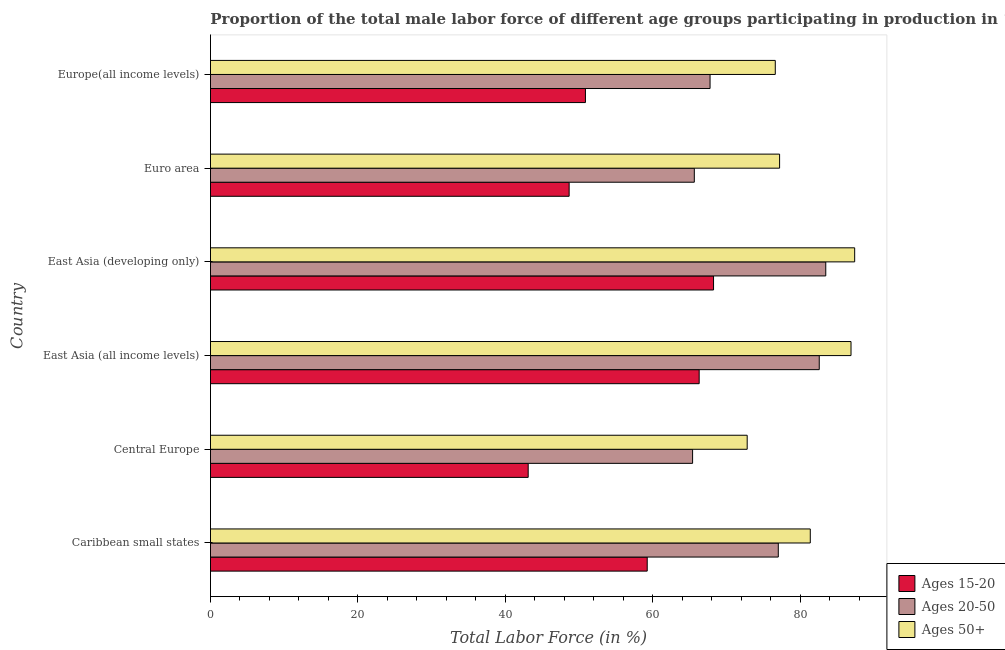How many groups of bars are there?
Provide a succinct answer. 6. Are the number of bars per tick equal to the number of legend labels?
Your response must be concise. Yes. Are the number of bars on each tick of the Y-axis equal?
Keep it short and to the point. Yes. How many bars are there on the 1st tick from the top?
Provide a short and direct response. 3. How many bars are there on the 6th tick from the bottom?
Offer a very short reply. 3. What is the label of the 1st group of bars from the top?
Offer a terse response. Europe(all income levels). What is the percentage of male labor force within the age group 20-50 in Euro area?
Offer a very short reply. 65.61. Across all countries, what is the maximum percentage of male labor force within the age group 20-50?
Make the answer very short. 83.43. Across all countries, what is the minimum percentage of male labor force within the age group 15-20?
Ensure brevity in your answer.  43.08. In which country was the percentage of male labor force within the age group 15-20 maximum?
Your answer should be compact. East Asia (developing only). In which country was the percentage of male labor force within the age group 15-20 minimum?
Offer a very short reply. Central Europe. What is the total percentage of male labor force within the age group 20-50 in the graph?
Your answer should be compact. 441.71. What is the difference between the percentage of male labor force above age 50 in Euro area and that in Europe(all income levels)?
Offer a very short reply. 0.58. What is the difference between the percentage of male labor force within the age group 20-50 in Central Europe and the percentage of male labor force within the age group 15-20 in Caribbean small states?
Make the answer very short. 6.15. What is the average percentage of male labor force within the age group 20-50 per country?
Offer a very short reply. 73.62. What is the difference between the percentage of male labor force within the age group 15-20 and percentage of male labor force above age 50 in Europe(all income levels)?
Your answer should be very brief. -25.74. What is the ratio of the percentage of male labor force within the age group 20-50 in Central Europe to that in East Asia (all income levels)?
Keep it short and to the point. 0.79. Is the percentage of male labor force above age 50 in Central Europe less than that in East Asia (developing only)?
Your answer should be compact. Yes. Is the difference between the percentage of male labor force above age 50 in Central Europe and East Asia (all income levels) greater than the difference between the percentage of male labor force within the age group 15-20 in Central Europe and East Asia (all income levels)?
Provide a short and direct response. Yes. What is the difference between the highest and the second highest percentage of male labor force within the age group 15-20?
Offer a terse response. 1.95. What is the difference between the highest and the lowest percentage of male labor force within the age group 15-20?
Your response must be concise. 25.14. What does the 2nd bar from the top in East Asia (all income levels) represents?
Offer a terse response. Ages 20-50. What does the 1st bar from the bottom in Euro area represents?
Your answer should be compact. Ages 15-20. How many bars are there?
Keep it short and to the point. 18. Are all the bars in the graph horizontal?
Your response must be concise. Yes. Does the graph contain any zero values?
Provide a short and direct response. No. Does the graph contain grids?
Ensure brevity in your answer.  No. Where does the legend appear in the graph?
Offer a very short reply. Bottom right. How are the legend labels stacked?
Offer a terse response. Vertical. What is the title of the graph?
Give a very brief answer. Proportion of the total male labor force of different age groups participating in production in 1999. What is the label or title of the X-axis?
Ensure brevity in your answer.  Total Labor Force (in %). What is the Total Labor Force (in %) of Ages 15-20 in Caribbean small states?
Make the answer very short. 59.22. What is the Total Labor Force (in %) of Ages 20-50 in Caribbean small states?
Your response must be concise. 77. What is the Total Labor Force (in %) of Ages 50+ in Caribbean small states?
Make the answer very short. 81.33. What is the Total Labor Force (in %) of Ages 15-20 in Central Europe?
Your answer should be very brief. 43.08. What is the Total Labor Force (in %) of Ages 20-50 in Central Europe?
Keep it short and to the point. 65.37. What is the Total Labor Force (in %) in Ages 50+ in Central Europe?
Make the answer very short. 72.78. What is the Total Labor Force (in %) in Ages 15-20 in East Asia (all income levels)?
Make the answer very short. 66.27. What is the Total Labor Force (in %) of Ages 20-50 in East Asia (all income levels)?
Make the answer very short. 82.55. What is the Total Labor Force (in %) of Ages 50+ in East Asia (all income levels)?
Offer a terse response. 86.86. What is the Total Labor Force (in %) in Ages 15-20 in East Asia (developing only)?
Keep it short and to the point. 68.22. What is the Total Labor Force (in %) in Ages 20-50 in East Asia (developing only)?
Give a very brief answer. 83.43. What is the Total Labor Force (in %) in Ages 50+ in East Asia (developing only)?
Keep it short and to the point. 87.35. What is the Total Labor Force (in %) in Ages 15-20 in Euro area?
Your answer should be very brief. 48.64. What is the Total Labor Force (in %) in Ages 20-50 in Euro area?
Provide a short and direct response. 65.61. What is the Total Labor Force (in %) of Ages 50+ in Euro area?
Your answer should be compact. 77.17. What is the Total Labor Force (in %) of Ages 15-20 in Europe(all income levels)?
Provide a succinct answer. 50.85. What is the Total Labor Force (in %) in Ages 20-50 in Europe(all income levels)?
Your answer should be compact. 67.74. What is the Total Labor Force (in %) of Ages 50+ in Europe(all income levels)?
Ensure brevity in your answer.  76.59. Across all countries, what is the maximum Total Labor Force (in %) in Ages 15-20?
Keep it short and to the point. 68.22. Across all countries, what is the maximum Total Labor Force (in %) in Ages 20-50?
Ensure brevity in your answer.  83.43. Across all countries, what is the maximum Total Labor Force (in %) in Ages 50+?
Provide a succinct answer. 87.35. Across all countries, what is the minimum Total Labor Force (in %) of Ages 15-20?
Offer a terse response. 43.08. Across all countries, what is the minimum Total Labor Force (in %) in Ages 20-50?
Ensure brevity in your answer.  65.37. Across all countries, what is the minimum Total Labor Force (in %) of Ages 50+?
Offer a terse response. 72.78. What is the total Total Labor Force (in %) in Ages 15-20 in the graph?
Your answer should be compact. 336.27. What is the total Total Labor Force (in %) in Ages 20-50 in the graph?
Provide a short and direct response. 441.71. What is the total Total Labor Force (in %) of Ages 50+ in the graph?
Your answer should be compact. 482.08. What is the difference between the Total Labor Force (in %) of Ages 15-20 in Caribbean small states and that in Central Europe?
Give a very brief answer. 16.14. What is the difference between the Total Labor Force (in %) of Ages 20-50 in Caribbean small states and that in Central Europe?
Make the answer very short. 11.62. What is the difference between the Total Labor Force (in %) of Ages 50+ in Caribbean small states and that in Central Europe?
Keep it short and to the point. 8.56. What is the difference between the Total Labor Force (in %) in Ages 15-20 in Caribbean small states and that in East Asia (all income levels)?
Your answer should be compact. -7.05. What is the difference between the Total Labor Force (in %) of Ages 20-50 in Caribbean small states and that in East Asia (all income levels)?
Your answer should be compact. -5.55. What is the difference between the Total Labor Force (in %) in Ages 50+ in Caribbean small states and that in East Asia (all income levels)?
Offer a terse response. -5.52. What is the difference between the Total Labor Force (in %) in Ages 15-20 in Caribbean small states and that in East Asia (developing only)?
Offer a very short reply. -9. What is the difference between the Total Labor Force (in %) of Ages 20-50 in Caribbean small states and that in East Asia (developing only)?
Your response must be concise. -6.44. What is the difference between the Total Labor Force (in %) of Ages 50+ in Caribbean small states and that in East Asia (developing only)?
Offer a terse response. -6.02. What is the difference between the Total Labor Force (in %) in Ages 15-20 in Caribbean small states and that in Euro area?
Offer a very short reply. 10.59. What is the difference between the Total Labor Force (in %) in Ages 20-50 in Caribbean small states and that in Euro area?
Offer a very short reply. 11.39. What is the difference between the Total Labor Force (in %) in Ages 50+ in Caribbean small states and that in Euro area?
Provide a short and direct response. 4.16. What is the difference between the Total Labor Force (in %) in Ages 15-20 in Caribbean small states and that in Europe(all income levels)?
Provide a short and direct response. 8.38. What is the difference between the Total Labor Force (in %) of Ages 20-50 in Caribbean small states and that in Europe(all income levels)?
Your answer should be compact. 9.25. What is the difference between the Total Labor Force (in %) of Ages 50+ in Caribbean small states and that in Europe(all income levels)?
Your answer should be compact. 4.75. What is the difference between the Total Labor Force (in %) in Ages 15-20 in Central Europe and that in East Asia (all income levels)?
Offer a very short reply. -23.19. What is the difference between the Total Labor Force (in %) in Ages 20-50 in Central Europe and that in East Asia (all income levels)?
Your answer should be very brief. -17.18. What is the difference between the Total Labor Force (in %) in Ages 50+ in Central Europe and that in East Asia (all income levels)?
Make the answer very short. -14.08. What is the difference between the Total Labor Force (in %) in Ages 15-20 in Central Europe and that in East Asia (developing only)?
Your answer should be very brief. -25.14. What is the difference between the Total Labor Force (in %) in Ages 20-50 in Central Europe and that in East Asia (developing only)?
Your response must be concise. -18.06. What is the difference between the Total Labor Force (in %) of Ages 50+ in Central Europe and that in East Asia (developing only)?
Your answer should be compact. -14.58. What is the difference between the Total Labor Force (in %) of Ages 15-20 in Central Europe and that in Euro area?
Your answer should be compact. -5.55. What is the difference between the Total Labor Force (in %) in Ages 20-50 in Central Europe and that in Euro area?
Ensure brevity in your answer.  -0.23. What is the difference between the Total Labor Force (in %) of Ages 50+ in Central Europe and that in Euro area?
Offer a very short reply. -4.39. What is the difference between the Total Labor Force (in %) in Ages 15-20 in Central Europe and that in Europe(all income levels)?
Give a very brief answer. -7.76. What is the difference between the Total Labor Force (in %) in Ages 20-50 in Central Europe and that in Europe(all income levels)?
Ensure brevity in your answer.  -2.37. What is the difference between the Total Labor Force (in %) of Ages 50+ in Central Europe and that in Europe(all income levels)?
Your answer should be compact. -3.81. What is the difference between the Total Labor Force (in %) of Ages 15-20 in East Asia (all income levels) and that in East Asia (developing only)?
Your answer should be compact. -1.95. What is the difference between the Total Labor Force (in %) in Ages 20-50 in East Asia (all income levels) and that in East Asia (developing only)?
Your answer should be compact. -0.88. What is the difference between the Total Labor Force (in %) of Ages 50+ in East Asia (all income levels) and that in East Asia (developing only)?
Ensure brevity in your answer.  -0.5. What is the difference between the Total Labor Force (in %) of Ages 15-20 in East Asia (all income levels) and that in Euro area?
Make the answer very short. 17.63. What is the difference between the Total Labor Force (in %) of Ages 20-50 in East Asia (all income levels) and that in Euro area?
Your response must be concise. 16.94. What is the difference between the Total Labor Force (in %) in Ages 50+ in East Asia (all income levels) and that in Euro area?
Offer a terse response. 9.68. What is the difference between the Total Labor Force (in %) in Ages 15-20 in East Asia (all income levels) and that in Europe(all income levels)?
Give a very brief answer. 15.42. What is the difference between the Total Labor Force (in %) in Ages 20-50 in East Asia (all income levels) and that in Europe(all income levels)?
Your response must be concise. 14.81. What is the difference between the Total Labor Force (in %) in Ages 50+ in East Asia (all income levels) and that in Europe(all income levels)?
Offer a very short reply. 10.27. What is the difference between the Total Labor Force (in %) in Ages 15-20 in East Asia (developing only) and that in Euro area?
Your answer should be very brief. 19.58. What is the difference between the Total Labor Force (in %) of Ages 20-50 in East Asia (developing only) and that in Euro area?
Make the answer very short. 17.83. What is the difference between the Total Labor Force (in %) in Ages 50+ in East Asia (developing only) and that in Euro area?
Provide a short and direct response. 10.18. What is the difference between the Total Labor Force (in %) of Ages 15-20 in East Asia (developing only) and that in Europe(all income levels)?
Give a very brief answer. 17.37. What is the difference between the Total Labor Force (in %) of Ages 20-50 in East Asia (developing only) and that in Europe(all income levels)?
Your answer should be compact. 15.69. What is the difference between the Total Labor Force (in %) in Ages 50+ in East Asia (developing only) and that in Europe(all income levels)?
Your response must be concise. 10.77. What is the difference between the Total Labor Force (in %) of Ages 15-20 in Euro area and that in Europe(all income levels)?
Provide a succinct answer. -2.21. What is the difference between the Total Labor Force (in %) of Ages 20-50 in Euro area and that in Europe(all income levels)?
Your response must be concise. -2.14. What is the difference between the Total Labor Force (in %) in Ages 50+ in Euro area and that in Europe(all income levels)?
Ensure brevity in your answer.  0.58. What is the difference between the Total Labor Force (in %) in Ages 15-20 in Caribbean small states and the Total Labor Force (in %) in Ages 20-50 in Central Europe?
Your response must be concise. -6.15. What is the difference between the Total Labor Force (in %) of Ages 15-20 in Caribbean small states and the Total Labor Force (in %) of Ages 50+ in Central Europe?
Your response must be concise. -13.56. What is the difference between the Total Labor Force (in %) in Ages 20-50 in Caribbean small states and the Total Labor Force (in %) in Ages 50+ in Central Europe?
Ensure brevity in your answer.  4.22. What is the difference between the Total Labor Force (in %) of Ages 15-20 in Caribbean small states and the Total Labor Force (in %) of Ages 20-50 in East Asia (all income levels)?
Ensure brevity in your answer.  -23.33. What is the difference between the Total Labor Force (in %) in Ages 15-20 in Caribbean small states and the Total Labor Force (in %) in Ages 50+ in East Asia (all income levels)?
Your response must be concise. -27.63. What is the difference between the Total Labor Force (in %) of Ages 20-50 in Caribbean small states and the Total Labor Force (in %) of Ages 50+ in East Asia (all income levels)?
Provide a succinct answer. -9.86. What is the difference between the Total Labor Force (in %) in Ages 15-20 in Caribbean small states and the Total Labor Force (in %) in Ages 20-50 in East Asia (developing only)?
Your answer should be very brief. -24.21. What is the difference between the Total Labor Force (in %) of Ages 15-20 in Caribbean small states and the Total Labor Force (in %) of Ages 50+ in East Asia (developing only)?
Your answer should be very brief. -28.13. What is the difference between the Total Labor Force (in %) of Ages 20-50 in Caribbean small states and the Total Labor Force (in %) of Ages 50+ in East Asia (developing only)?
Give a very brief answer. -10.36. What is the difference between the Total Labor Force (in %) in Ages 15-20 in Caribbean small states and the Total Labor Force (in %) in Ages 20-50 in Euro area?
Ensure brevity in your answer.  -6.39. What is the difference between the Total Labor Force (in %) of Ages 15-20 in Caribbean small states and the Total Labor Force (in %) of Ages 50+ in Euro area?
Ensure brevity in your answer.  -17.95. What is the difference between the Total Labor Force (in %) of Ages 20-50 in Caribbean small states and the Total Labor Force (in %) of Ages 50+ in Euro area?
Provide a short and direct response. -0.18. What is the difference between the Total Labor Force (in %) in Ages 15-20 in Caribbean small states and the Total Labor Force (in %) in Ages 20-50 in Europe(all income levels)?
Your answer should be very brief. -8.52. What is the difference between the Total Labor Force (in %) of Ages 15-20 in Caribbean small states and the Total Labor Force (in %) of Ages 50+ in Europe(all income levels)?
Offer a very short reply. -17.37. What is the difference between the Total Labor Force (in %) of Ages 20-50 in Caribbean small states and the Total Labor Force (in %) of Ages 50+ in Europe(all income levels)?
Make the answer very short. 0.41. What is the difference between the Total Labor Force (in %) in Ages 15-20 in Central Europe and the Total Labor Force (in %) in Ages 20-50 in East Asia (all income levels)?
Provide a succinct answer. -39.47. What is the difference between the Total Labor Force (in %) in Ages 15-20 in Central Europe and the Total Labor Force (in %) in Ages 50+ in East Asia (all income levels)?
Make the answer very short. -43.77. What is the difference between the Total Labor Force (in %) of Ages 20-50 in Central Europe and the Total Labor Force (in %) of Ages 50+ in East Asia (all income levels)?
Provide a succinct answer. -21.48. What is the difference between the Total Labor Force (in %) in Ages 15-20 in Central Europe and the Total Labor Force (in %) in Ages 20-50 in East Asia (developing only)?
Give a very brief answer. -40.35. What is the difference between the Total Labor Force (in %) of Ages 15-20 in Central Europe and the Total Labor Force (in %) of Ages 50+ in East Asia (developing only)?
Your response must be concise. -44.27. What is the difference between the Total Labor Force (in %) of Ages 20-50 in Central Europe and the Total Labor Force (in %) of Ages 50+ in East Asia (developing only)?
Provide a short and direct response. -21.98. What is the difference between the Total Labor Force (in %) in Ages 15-20 in Central Europe and the Total Labor Force (in %) in Ages 20-50 in Euro area?
Your answer should be compact. -22.53. What is the difference between the Total Labor Force (in %) in Ages 15-20 in Central Europe and the Total Labor Force (in %) in Ages 50+ in Euro area?
Offer a terse response. -34.09. What is the difference between the Total Labor Force (in %) of Ages 20-50 in Central Europe and the Total Labor Force (in %) of Ages 50+ in Euro area?
Keep it short and to the point. -11.8. What is the difference between the Total Labor Force (in %) in Ages 15-20 in Central Europe and the Total Labor Force (in %) in Ages 20-50 in Europe(all income levels)?
Ensure brevity in your answer.  -24.66. What is the difference between the Total Labor Force (in %) in Ages 15-20 in Central Europe and the Total Labor Force (in %) in Ages 50+ in Europe(all income levels)?
Ensure brevity in your answer.  -33.51. What is the difference between the Total Labor Force (in %) in Ages 20-50 in Central Europe and the Total Labor Force (in %) in Ages 50+ in Europe(all income levels)?
Make the answer very short. -11.21. What is the difference between the Total Labor Force (in %) in Ages 15-20 in East Asia (all income levels) and the Total Labor Force (in %) in Ages 20-50 in East Asia (developing only)?
Provide a short and direct response. -17.17. What is the difference between the Total Labor Force (in %) of Ages 15-20 in East Asia (all income levels) and the Total Labor Force (in %) of Ages 50+ in East Asia (developing only)?
Offer a terse response. -21.09. What is the difference between the Total Labor Force (in %) of Ages 20-50 in East Asia (all income levels) and the Total Labor Force (in %) of Ages 50+ in East Asia (developing only)?
Offer a terse response. -4.8. What is the difference between the Total Labor Force (in %) in Ages 15-20 in East Asia (all income levels) and the Total Labor Force (in %) in Ages 20-50 in Euro area?
Your answer should be compact. 0.66. What is the difference between the Total Labor Force (in %) of Ages 15-20 in East Asia (all income levels) and the Total Labor Force (in %) of Ages 50+ in Euro area?
Offer a terse response. -10.9. What is the difference between the Total Labor Force (in %) in Ages 20-50 in East Asia (all income levels) and the Total Labor Force (in %) in Ages 50+ in Euro area?
Provide a short and direct response. 5.38. What is the difference between the Total Labor Force (in %) in Ages 15-20 in East Asia (all income levels) and the Total Labor Force (in %) in Ages 20-50 in Europe(all income levels)?
Ensure brevity in your answer.  -1.48. What is the difference between the Total Labor Force (in %) in Ages 15-20 in East Asia (all income levels) and the Total Labor Force (in %) in Ages 50+ in Europe(all income levels)?
Provide a succinct answer. -10.32. What is the difference between the Total Labor Force (in %) in Ages 20-50 in East Asia (all income levels) and the Total Labor Force (in %) in Ages 50+ in Europe(all income levels)?
Your answer should be compact. 5.96. What is the difference between the Total Labor Force (in %) in Ages 15-20 in East Asia (developing only) and the Total Labor Force (in %) in Ages 20-50 in Euro area?
Offer a terse response. 2.61. What is the difference between the Total Labor Force (in %) of Ages 15-20 in East Asia (developing only) and the Total Labor Force (in %) of Ages 50+ in Euro area?
Your answer should be very brief. -8.95. What is the difference between the Total Labor Force (in %) in Ages 20-50 in East Asia (developing only) and the Total Labor Force (in %) in Ages 50+ in Euro area?
Your response must be concise. 6.26. What is the difference between the Total Labor Force (in %) in Ages 15-20 in East Asia (developing only) and the Total Labor Force (in %) in Ages 20-50 in Europe(all income levels)?
Your answer should be very brief. 0.47. What is the difference between the Total Labor Force (in %) of Ages 15-20 in East Asia (developing only) and the Total Labor Force (in %) of Ages 50+ in Europe(all income levels)?
Provide a short and direct response. -8.37. What is the difference between the Total Labor Force (in %) of Ages 20-50 in East Asia (developing only) and the Total Labor Force (in %) of Ages 50+ in Europe(all income levels)?
Provide a short and direct response. 6.85. What is the difference between the Total Labor Force (in %) in Ages 15-20 in Euro area and the Total Labor Force (in %) in Ages 20-50 in Europe(all income levels)?
Your response must be concise. -19.11. What is the difference between the Total Labor Force (in %) of Ages 15-20 in Euro area and the Total Labor Force (in %) of Ages 50+ in Europe(all income levels)?
Ensure brevity in your answer.  -27.95. What is the difference between the Total Labor Force (in %) of Ages 20-50 in Euro area and the Total Labor Force (in %) of Ages 50+ in Europe(all income levels)?
Provide a short and direct response. -10.98. What is the average Total Labor Force (in %) of Ages 15-20 per country?
Your response must be concise. 56.05. What is the average Total Labor Force (in %) in Ages 20-50 per country?
Keep it short and to the point. 73.62. What is the average Total Labor Force (in %) in Ages 50+ per country?
Your answer should be compact. 80.35. What is the difference between the Total Labor Force (in %) of Ages 15-20 and Total Labor Force (in %) of Ages 20-50 in Caribbean small states?
Your answer should be compact. -17.77. What is the difference between the Total Labor Force (in %) of Ages 15-20 and Total Labor Force (in %) of Ages 50+ in Caribbean small states?
Your answer should be very brief. -22.11. What is the difference between the Total Labor Force (in %) in Ages 20-50 and Total Labor Force (in %) in Ages 50+ in Caribbean small states?
Your answer should be very brief. -4.34. What is the difference between the Total Labor Force (in %) of Ages 15-20 and Total Labor Force (in %) of Ages 20-50 in Central Europe?
Keep it short and to the point. -22.29. What is the difference between the Total Labor Force (in %) of Ages 15-20 and Total Labor Force (in %) of Ages 50+ in Central Europe?
Ensure brevity in your answer.  -29.7. What is the difference between the Total Labor Force (in %) in Ages 20-50 and Total Labor Force (in %) in Ages 50+ in Central Europe?
Keep it short and to the point. -7.4. What is the difference between the Total Labor Force (in %) in Ages 15-20 and Total Labor Force (in %) in Ages 20-50 in East Asia (all income levels)?
Your response must be concise. -16.28. What is the difference between the Total Labor Force (in %) of Ages 15-20 and Total Labor Force (in %) of Ages 50+ in East Asia (all income levels)?
Give a very brief answer. -20.59. What is the difference between the Total Labor Force (in %) in Ages 20-50 and Total Labor Force (in %) in Ages 50+ in East Asia (all income levels)?
Provide a succinct answer. -4.31. What is the difference between the Total Labor Force (in %) of Ages 15-20 and Total Labor Force (in %) of Ages 20-50 in East Asia (developing only)?
Your answer should be compact. -15.22. What is the difference between the Total Labor Force (in %) in Ages 15-20 and Total Labor Force (in %) in Ages 50+ in East Asia (developing only)?
Your answer should be very brief. -19.14. What is the difference between the Total Labor Force (in %) of Ages 20-50 and Total Labor Force (in %) of Ages 50+ in East Asia (developing only)?
Provide a succinct answer. -3.92. What is the difference between the Total Labor Force (in %) of Ages 15-20 and Total Labor Force (in %) of Ages 20-50 in Euro area?
Your response must be concise. -16.97. What is the difference between the Total Labor Force (in %) of Ages 15-20 and Total Labor Force (in %) of Ages 50+ in Euro area?
Your response must be concise. -28.54. What is the difference between the Total Labor Force (in %) of Ages 20-50 and Total Labor Force (in %) of Ages 50+ in Euro area?
Keep it short and to the point. -11.56. What is the difference between the Total Labor Force (in %) in Ages 15-20 and Total Labor Force (in %) in Ages 20-50 in Europe(all income levels)?
Keep it short and to the point. -16.9. What is the difference between the Total Labor Force (in %) of Ages 15-20 and Total Labor Force (in %) of Ages 50+ in Europe(all income levels)?
Give a very brief answer. -25.74. What is the difference between the Total Labor Force (in %) in Ages 20-50 and Total Labor Force (in %) in Ages 50+ in Europe(all income levels)?
Your answer should be very brief. -8.84. What is the ratio of the Total Labor Force (in %) of Ages 15-20 in Caribbean small states to that in Central Europe?
Offer a terse response. 1.37. What is the ratio of the Total Labor Force (in %) of Ages 20-50 in Caribbean small states to that in Central Europe?
Make the answer very short. 1.18. What is the ratio of the Total Labor Force (in %) of Ages 50+ in Caribbean small states to that in Central Europe?
Your response must be concise. 1.12. What is the ratio of the Total Labor Force (in %) of Ages 15-20 in Caribbean small states to that in East Asia (all income levels)?
Offer a very short reply. 0.89. What is the ratio of the Total Labor Force (in %) of Ages 20-50 in Caribbean small states to that in East Asia (all income levels)?
Offer a terse response. 0.93. What is the ratio of the Total Labor Force (in %) of Ages 50+ in Caribbean small states to that in East Asia (all income levels)?
Provide a succinct answer. 0.94. What is the ratio of the Total Labor Force (in %) of Ages 15-20 in Caribbean small states to that in East Asia (developing only)?
Offer a terse response. 0.87. What is the ratio of the Total Labor Force (in %) in Ages 20-50 in Caribbean small states to that in East Asia (developing only)?
Ensure brevity in your answer.  0.92. What is the ratio of the Total Labor Force (in %) of Ages 50+ in Caribbean small states to that in East Asia (developing only)?
Keep it short and to the point. 0.93. What is the ratio of the Total Labor Force (in %) in Ages 15-20 in Caribbean small states to that in Euro area?
Ensure brevity in your answer.  1.22. What is the ratio of the Total Labor Force (in %) in Ages 20-50 in Caribbean small states to that in Euro area?
Provide a succinct answer. 1.17. What is the ratio of the Total Labor Force (in %) of Ages 50+ in Caribbean small states to that in Euro area?
Keep it short and to the point. 1.05. What is the ratio of the Total Labor Force (in %) in Ages 15-20 in Caribbean small states to that in Europe(all income levels)?
Give a very brief answer. 1.16. What is the ratio of the Total Labor Force (in %) of Ages 20-50 in Caribbean small states to that in Europe(all income levels)?
Make the answer very short. 1.14. What is the ratio of the Total Labor Force (in %) in Ages 50+ in Caribbean small states to that in Europe(all income levels)?
Offer a terse response. 1.06. What is the ratio of the Total Labor Force (in %) in Ages 15-20 in Central Europe to that in East Asia (all income levels)?
Keep it short and to the point. 0.65. What is the ratio of the Total Labor Force (in %) of Ages 20-50 in Central Europe to that in East Asia (all income levels)?
Provide a succinct answer. 0.79. What is the ratio of the Total Labor Force (in %) in Ages 50+ in Central Europe to that in East Asia (all income levels)?
Provide a succinct answer. 0.84. What is the ratio of the Total Labor Force (in %) in Ages 15-20 in Central Europe to that in East Asia (developing only)?
Your answer should be compact. 0.63. What is the ratio of the Total Labor Force (in %) in Ages 20-50 in Central Europe to that in East Asia (developing only)?
Your response must be concise. 0.78. What is the ratio of the Total Labor Force (in %) of Ages 50+ in Central Europe to that in East Asia (developing only)?
Offer a very short reply. 0.83. What is the ratio of the Total Labor Force (in %) in Ages 15-20 in Central Europe to that in Euro area?
Provide a short and direct response. 0.89. What is the ratio of the Total Labor Force (in %) in Ages 50+ in Central Europe to that in Euro area?
Your answer should be very brief. 0.94. What is the ratio of the Total Labor Force (in %) in Ages 15-20 in Central Europe to that in Europe(all income levels)?
Your answer should be very brief. 0.85. What is the ratio of the Total Labor Force (in %) in Ages 20-50 in Central Europe to that in Europe(all income levels)?
Ensure brevity in your answer.  0.96. What is the ratio of the Total Labor Force (in %) of Ages 50+ in Central Europe to that in Europe(all income levels)?
Ensure brevity in your answer.  0.95. What is the ratio of the Total Labor Force (in %) of Ages 15-20 in East Asia (all income levels) to that in East Asia (developing only)?
Offer a very short reply. 0.97. What is the ratio of the Total Labor Force (in %) in Ages 20-50 in East Asia (all income levels) to that in East Asia (developing only)?
Your answer should be very brief. 0.99. What is the ratio of the Total Labor Force (in %) in Ages 50+ in East Asia (all income levels) to that in East Asia (developing only)?
Provide a short and direct response. 0.99. What is the ratio of the Total Labor Force (in %) in Ages 15-20 in East Asia (all income levels) to that in Euro area?
Offer a terse response. 1.36. What is the ratio of the Total Labor Force (in %) of Ages 20-50 in East Asia (all income levels) to that in Euro area?
Make the answer very short. 1.26. What is the ratio of the Total Labor Force (in %) of Ages 50+ in East Asia (all income levels) to that in Euro area?
Keep it short and to the point. 1.13. What is the ratio of the Total Labor Force (in %) of Ages 15-20 in East Asia (all income levels) to that in Europe(all income levels)?
Provide a succinct answer. 1.3. What is the ratio of the Total Labor Force (in %) of Ages 20-50 in East Asia (all income levels) to that in Europe(all income levels)?
Provide a succinct answer. 1.22. What is the ratio of the Total Labor Force (in %) of Ages 50+ in East Asia (all income levels) to that in Europe(all income levels)?
Make the answer very short. 1.13. What is the ratio of the Total Labor Force (in %) of Ages 15-20 in East Asia (developing only) to that in Euro area?
Give a very brief answer. 1.4. What is the ratio of the Total Labor Force (in %) in Ages 20-50 in East Asia (developing only) to that in Euro area?
Ensure brevity in your answer.  1.27. What is the ratio of the Total Labor Force (in %) in Ages 50+ in East Asia (developing only) to that in Euro area?
Offer a terse response. 1.13. What is the ratio of the Total Labor Force (in %) in Ages 15-20 in East Asia (developing only) to that in Europe(all income levels)?
Your answer should be compact. 1.34. What is the ratio of the Total Labor Force (in %) of Ages 20-50 in East Asia (developing only) to that in Europe(all income levels)?
Provide a short and direct response. 1.23. What is the ratio of the Total Labor Force (in %) in Ages 50+ in East Asia (developing only) to that in Europe(all income levels)?
Your answer should be very brief. 1.14. What is the ratio of the Total Labor Force (in %) of Ages 15-20 in Euro area to that in Europe(all income levels)?
Your response must be concise. 0.96. What is the ratio of the Total Labor Force (in %) in Ages 20-50 in Euro area to that in Europe(all income levels)?
Your response must be concise. 0.97. What is the ratio of the Total Labor Force (in %) of Ages 50+ in Euro area to that in Europe(all income levels)?
Provide a succinct answer. 1.01. What is the difference between the highest and the second highest Total Labor Force (in %) of Ages 15-20?
Provide a succinct answer. 1.95. What is the difference between the highest and the second highest Total Labor Force (in %) in Ages 20-50?
Keep it short and to the point. 0.88. What is the difference between the highest and the second highest Total Labor Force (in %) in Ages 50+?
Provide a succinct answer. 0.5. What is the difference between the highest and the lowest Total Labor Force (in %) in Ages 15-20?
Offer a very short reply. 25.14. What is the difference between the highest and the lowest Total Labor Force (in %) of Ages 20-50?
Provide a succinct answer. 18.06. What is the difference between the highest and the lowest Total Labor Force (in %) in Ages 50+?
Give a very brief answer. 14.58. 